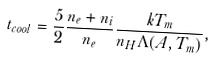<formula> <loc_0><loc_0><loc_500><loc_500>t _ { c o o l } = \frac { 5 } { 2 } \frac { n _ { e } + n _ { i } } { n _ { e } } \frac { k T _ { m } } { n _ { H } \Lambda ( A , T _ { m } ) } ,</formula> 